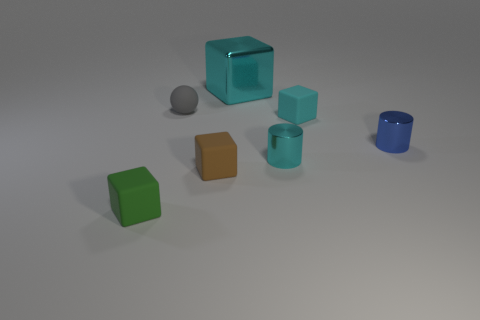Subtract all tiny rubber blocks. How many blocks are left? 1 Subtract all green cylinders. How many cyan cubes are left? 2 Add 1 small cyan rubber balls. How many objects exist? 8 Subtract 1 cubes. How many cubes are left? 3 Subtract all green cubes. How many cubes are left? 3 Subtract all balls. How many objects are left? 6 Add 6 big cyan things. How many big cyan things are left? 7 Add 6 small gray matte things. How many small gray matte things exist? 7 Subtract 1 blue cylinders. How many objects are left? 6 Subtract all cyan cylinders. Subtract all yellow balls. How many cylinders are left? 1 